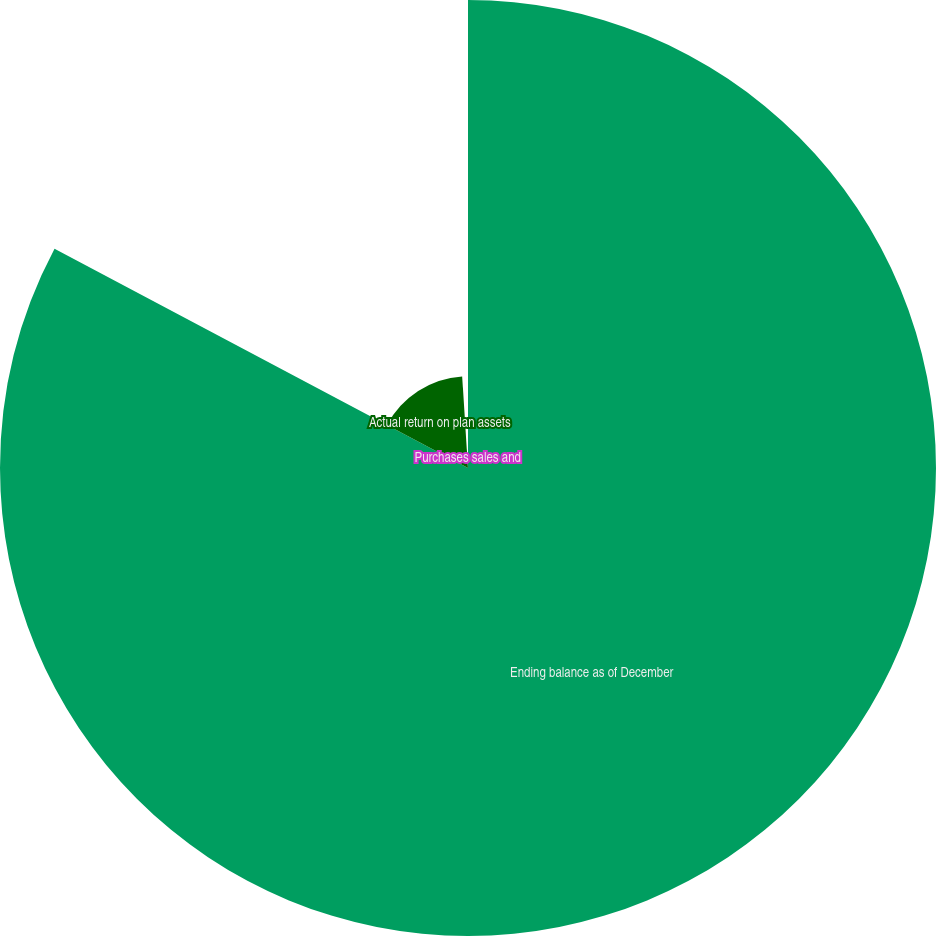Convert chart to OTSL. <chart><loc_0><loc_0><loc_500><loc_500><pie_chart><fcel>Ending balance as of December<fcel>Actual return on plan assets<fcel>Purchases sales and<nl><fcel>82.76%<fcel>16.23%<fcel>1.01%<nl></chart> 